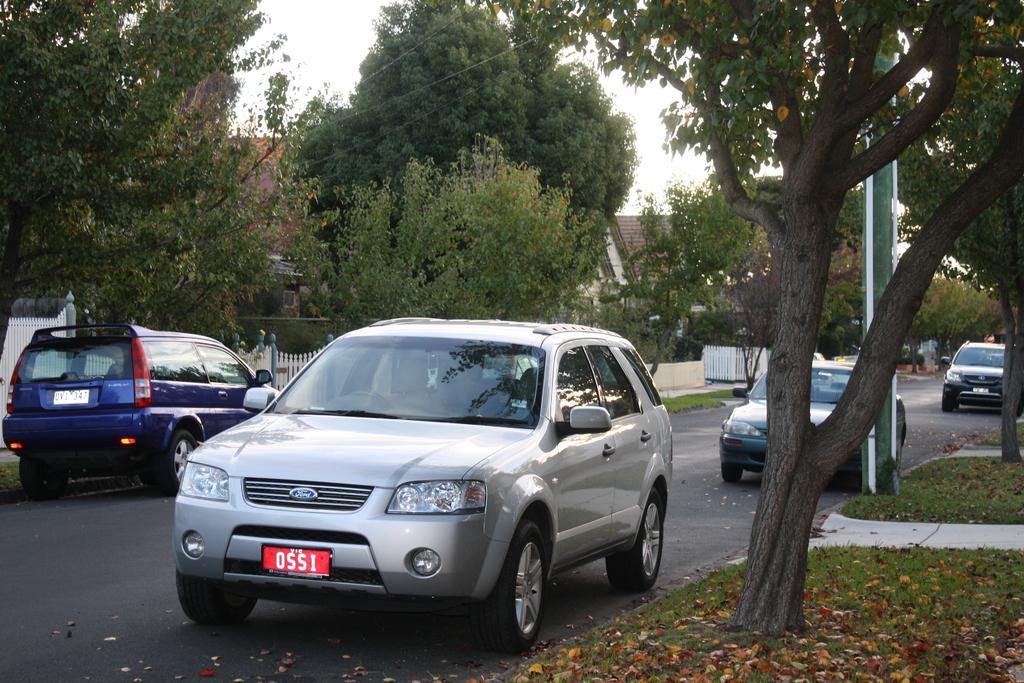Please provide a concise description of this image. In this image we can see motor vehicles on the road, shredded leaves on the ground, trees, buildings, wooden grills and sky. 